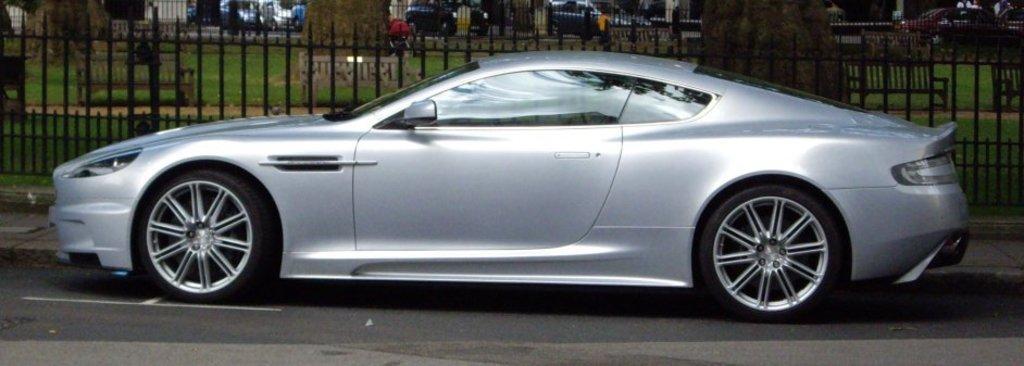Please provide a concise description of this image. In the center of the image we can see a car on the road. In the background there is a fence, benches and vehicles. 